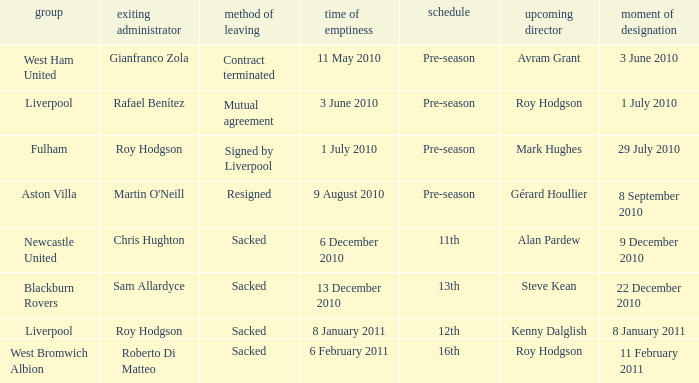What team has an incoming manager named Kenny Dalglish? Liverpool. 